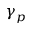<formula> <loc_0><loc_0><loc_500><loc_500>\gamma _ { p }</formula> 